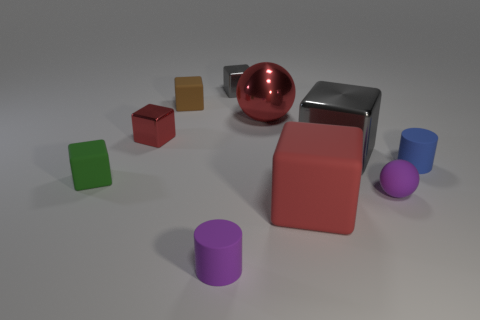How many big metallic things have the same shape as the tiny brown object?
Your answer should be very brief. 1. Is the material of the large gray object the same as the small sphere in front of the small brown object?
Your response must be concise. No. How many big gray cubes are there?
Provide a short and direct response. 1. There is a matte block on the left side of the brown matte cube; what is its size?
Offer a terse response. Small. What number of red things are the same size as the blue rubber object?
Your answer should be compact. 1. There is a small object that is both to the right of the large gray shiny thing and in front of the small blue rubber object; what material is it?
Ensure brevity in your answer.  Rubber. There is a gray block that is the same size as the blue cylinder; what is it made of?
Keep it short and to the point. Metal. How big is the ball behind the small cylinder that is to the right of the rubber cylinder that is to the left of the large red sphere?
Provide a short and direct response. Large. There is another gray block that is made of the same material as the small gray block; what size is it?
Provide a short and direct response. Large. There is a green cube; does it have the same size as the metal sphere that is to the right of the tiny red object?
Your response must be concise. No. 